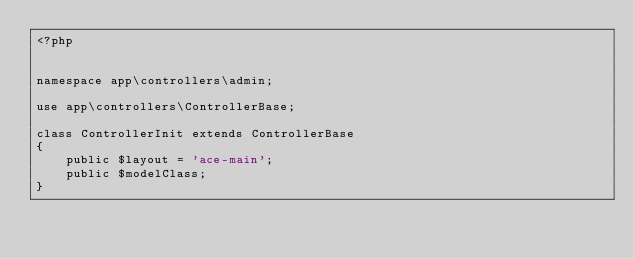<code> <loc_0><loc_0><loc_500><loc_500><_PHP_><?php


namespace app\controllers\admin;

use app\controllers\ControllerBase;

class ControllerInit extends ControllerBase
{
    public $layout = 'ace-main';
    public $modelClass;
}</code> 